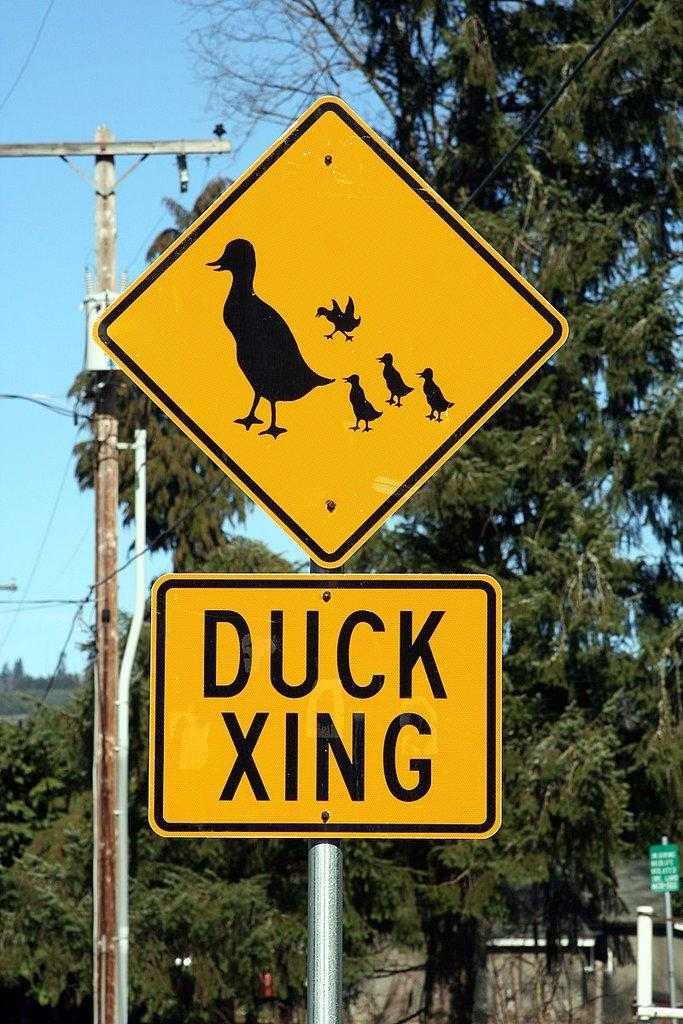Provide a one-sentence caption for the provided image. street sign warning about duck crossing the street. 